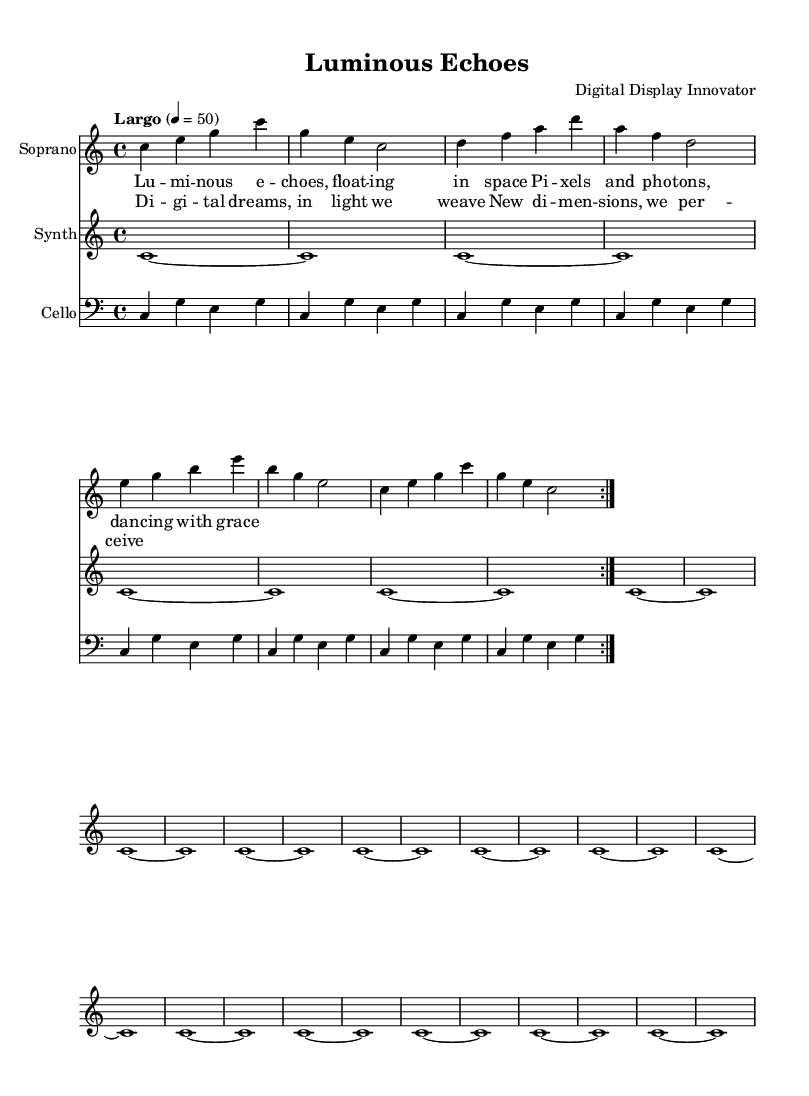What is the key signature of this music? The key signature is C major, which has no sharps or flats.
Answer: C major What is the time signature of this piece? The time signature indicated in the music is 4/4, which means there are four beats in each measure.
Answer: 4/4 What is the tempo marking for this piece? The tempo marking is "Largo," indicating a slow pace, and it is specified to be set at a metronome marking of 50 beats per minute.
Answer: Largo How many times are the soprano’s opening phrases repeated? The soprano's opening phrases are indicated to repeat with a volta marking, which shows they are repeated twice before moving on.
Answer: 2 What instruments are featured in this score? The score includes a soprano, synthesizer, and cello, as labeled in the staff layout.
Answer: Soprano, Synth, Cello How many measures are in the cello part? The cello part consists of 8 measures, as shown by the repeated section in the code.
Answer: 8 What visual themes do the lyrics suggest for the opera? The lyrics suggest themes of light, space, and digital experiences, reflecting an abstract visual concept in line with minimalist opera trends.
Answer: Pixels and photons 